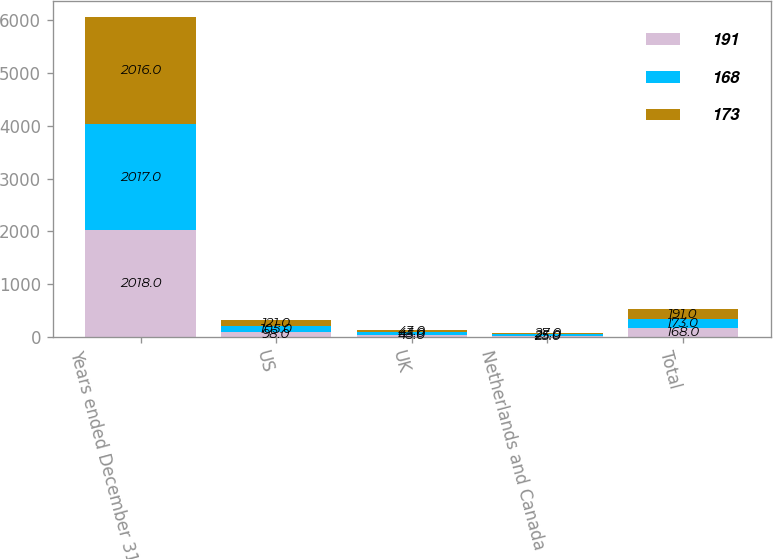<chart> <loc_0><loc_0><loc_500><loc_500><stacked_bar_chart><ecel><fcel>Years ended December 31<fcel>US<fcel>UK<fcel>Netherlands and Canada<fcel>Total<nl><fcel>191<fcel>2018<fcel>98<fcel>45<fcel>25<fcel>168<nl><fcel>168<fcel>2017<fcel>105<fcel>43<fcel>25<fcel>173<nl><fcel>173<fcel>2016<fcel>121<fcel>43<fcel>27<fcel>191<nl></chart> 